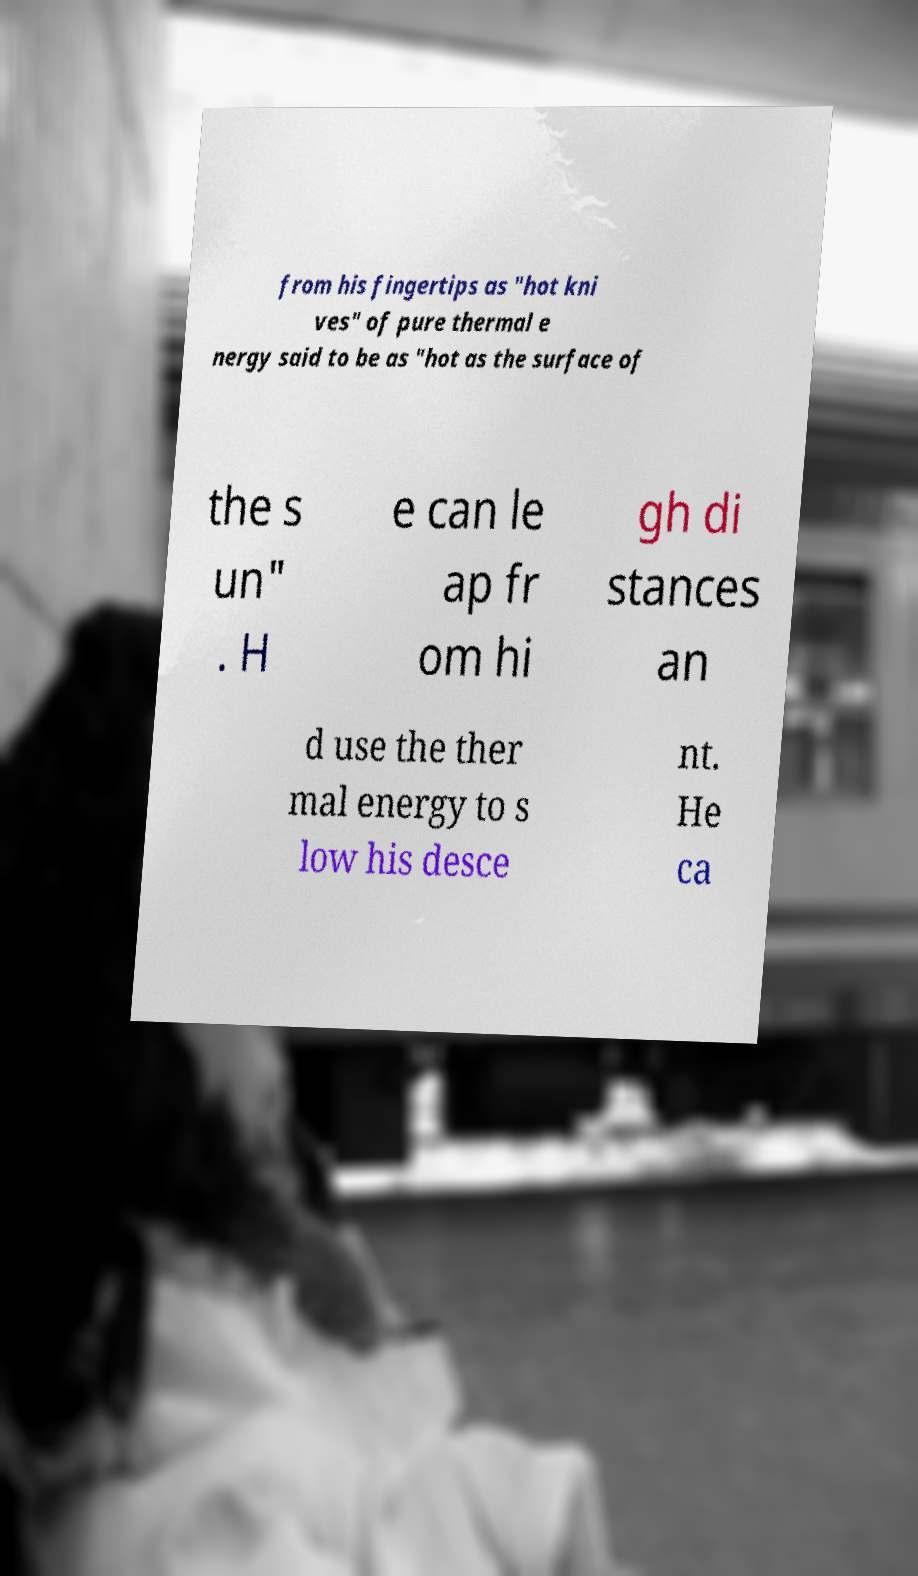Can you read and provide the text displayed in the image?This photo seems to have some interesting text. Can you extract and type it out for me? from his fingertips as "hot kni ves" of pure thermal e nergy said to be as "hot as the surface of the s un" . H e can le ap fr om hi gh di stances an d use the ther mal energy to s low his desce nt. He ca 